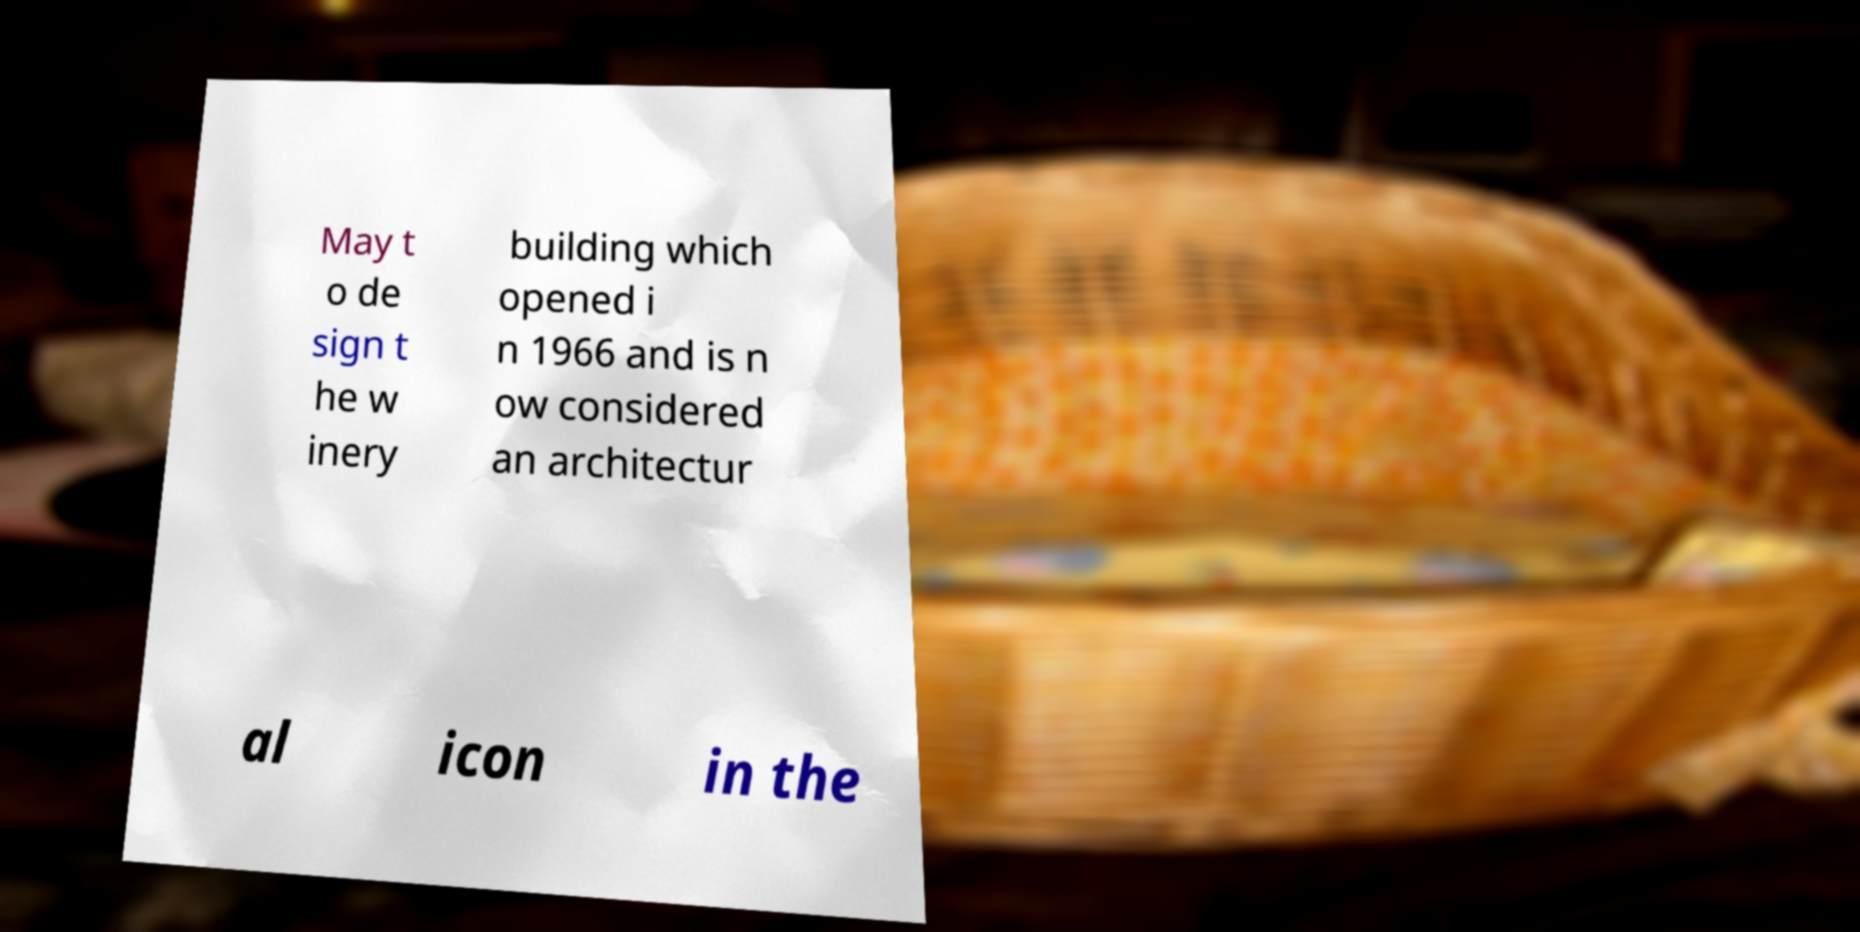Could you extract and type out the text from this image? May t o de sign t he w inery building which opened i n 1966 and is n ow considered an architectur al icon in the 